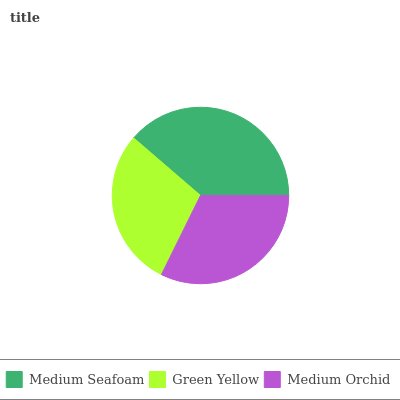Is Green Yellow the minimum?
Answer yes or no. Yes. Is Medium Seafoam the maximum?
Answer yes or no. Yes. Is Medium Orchid the minimum?
Answer yes or no. No. Is Medium Orchid the maximum?
Answer yes or no. No. Is Medium Orchid greater than Green Yellow?
Answer yes or no. Yes. Is Green Yellow less than Medium Orchid?
Answer yes or no. Yes. Is Green Yellow greater than Medium Orchid?
Answer yes or no. No. Is Medium Orchid less than Green Yellow?
Answer yes or no. No. Is Medium Orchid the high median?
Answer yes or no. Yes. Is Medium Orchid the low median?
Answer yes or no. Yes. Is Green Yellow the high median?
Answer yes or no. No. Is Medium Seafoam the low median?
Answer yes or no. No. 